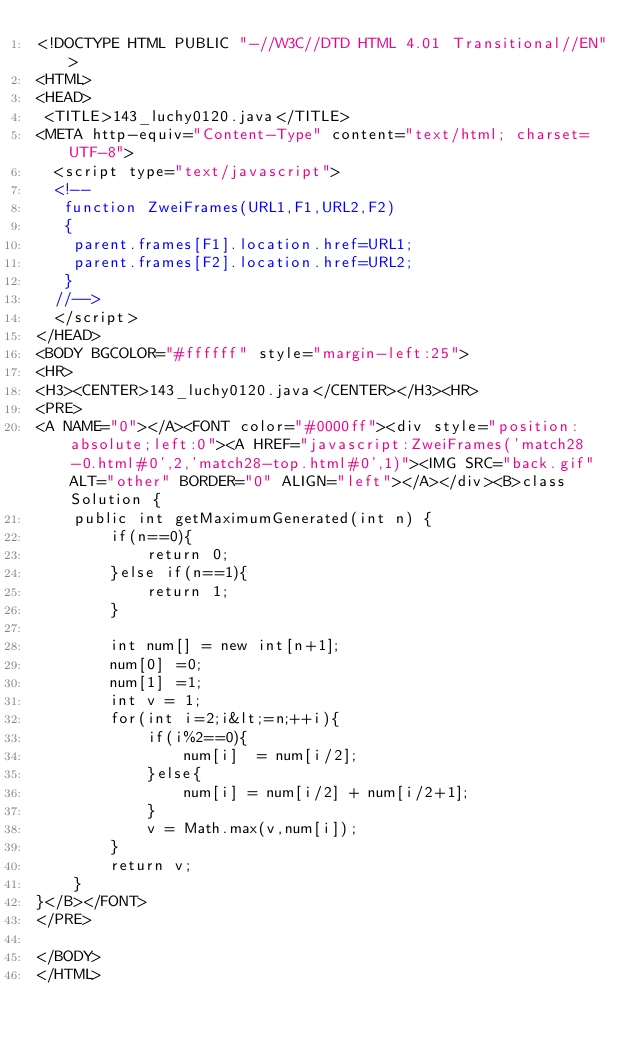Convert code to text. <code><loc_0><loc_0><loc_500><loc_500><_HTML_><!DOCTYPE HTML PUBLIC "-//W3C//DTD HTML 4.01 Transitional//EN">
<HTML>
<HEAD>
 <TITLE>143_luchy0120.java</TITLE>
<META http-equiv="Content-Type" content="text/html; charset=UTF-8">
  <script type="text/javascript">
  <!--
   function ZweiFrames(URL1,F1,URL2,F2)
   {
    parent.frames[F1].location.href=URL1;
    parent.frames[F2].location.href=URL2;
   }
  //-->
  </script>
</HEAD>
<BODY BGCOLOR="#ffffff" style="margin-left:25">
<HR>
<H3><CENTER>143_luchy0120.java</CENTER></H3><HR>
<PRE>
<A NAME="0"></A><FONT color="#0000ff"><div style="position:absolute;left:0"><A HREF="javascript:ZweiFrames('match28-0.html#0',2,'match28-top.html#0',1)"><IMG SRC="back.gif" ALT="other" BORDER="0" ALIGN="left"></A></div><B>class Solution {
    public int getMaximumGenerated(int n) {
        if(n==0){
            return 0;
        }else if(n==1){
            return 1;
        }
        
        int num[] = new int[n+1];
        num[0] =0;
        num[1] =1;
        int v = 1;
        for(int i=2;i&lt;=n;++i){
            if(i%2==0){
                num[i]  = num[i/2];
            }else{
                num[i] = num[i/2] + num[i/2+1];
            }
            v = Math.max(v,num[i]);
        }
        return v;
    }
}</B></FONT>
</PRE>

</BODY>
</HTML>
</code> 